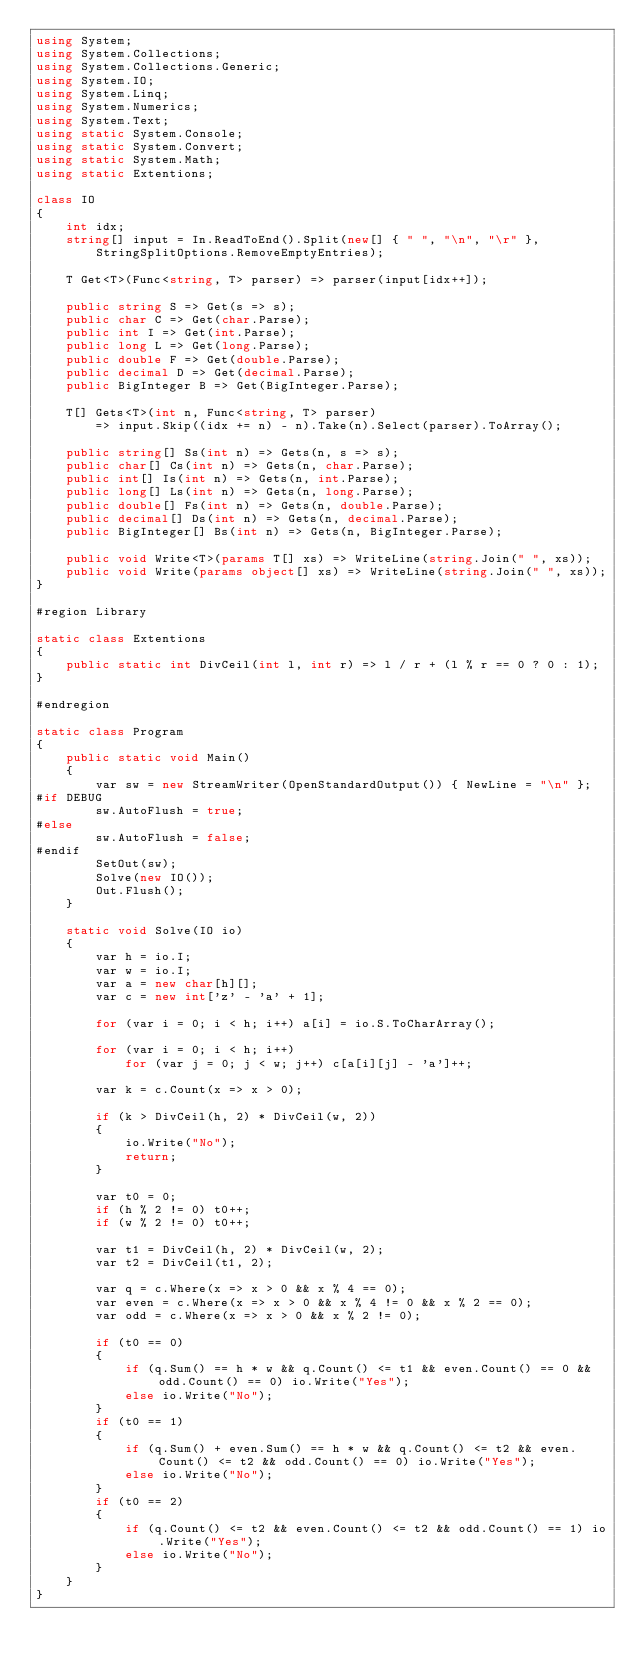<code> <loc_0><loc_0><loc_500><loc_500><_C#_>using System;
using System.Collections;
using System.Collections.Generic;
using System.IO;
using System.Linq;
using System.Numerics;
using System.Text;
using static System.Console;
using static System.Convert;
using static System.Math;
using static Extentions;

class IO
{
    int idx;
    string[] input = In.ReadToEnd().Split(new[] { " ", "\n", "\r" },
        StringSplitOptions.RemoveEmptyEntries);

    T Get<T>(Func<string, T> parser) => parser(input[idx++]);

    public string S => Get(s => s);
    public char C => Get(char.Parse);
    public int I => Get(int.Parse);
    public long L => Get(long.Parse);
    public double F => Get(double.Parse);
    public decimal D => Get(decimal.Parse);
    public BigInteger B => Get(BigInteger.Parse);

    T[] Gets<T>(int n, Func<string, T> parser)
        => input.Skip((idx += n) - n).Take(n).Select(parser).ToArray();

    public string[] Ss(int n) => Gets(n, s => s);
    public char[] Cs(int n) => Gets(n, char.Parse);
    public int[] Is(int n) => Gets(n, int.Parse);
    public long[] Ls(int n) => Gets(n, long.Parse);
    public double[] Fs(int n) => Gets(n, double.Parse);
    public decimal[] Ds(int n) => Gets(n, decimal.Parse);
    public BigInteger[] Bs(int n) => Gets(n, BigInteger.Parse);

    public void Write<T>(params T[] xs) => WriteLine(string.Join(" ", xs));
    public void Write(params object[] xs) => WriteLine(string.Join(" ", xs));
}

#region Library

static class Extentions
{
    public static int DivCeil(int l, int r) => l / r + (l % r == 0 ? 0 : 1);
}

#endregion

static class Program
{
    public static void Main()
    {
        var sw = new StreamWriter(OpenStandardOutput()) { NewLine = "\n" };
#if DEBUG
        sw.AutoFlush = true;
#else
        sw.AutoFlush = false;
#endif
        SetOut(sw);
        Solve(new IO());
        Out.Flush();
    }

    static void Solve(IO io)
    {
        var h = io.I;
        var w = io.I;
        var a = new char[h][];
        var c = new int['z' - 'a' + 1];

        for (var i = 0; i < h; i++) a[i] = io.S.ToCharArray();

        for (var i = 0; i < h; i++)
            for (var j = 0; j < w; j++) c[a[i][j] - 'a']++;

        var k = c.Count(x => x > 0);

        if (k > DivCeil(h, 2) * DivCeil(w, 2))
        {
            io.Write("No");
            return;
        }

        var t0 = 0;
        if (h % 2 != 0) t0++;
        if (w % 2 != 0) t0++;

        var t1 = DivCeil(h, 2) * DivCeil(w, 2);
        var t2 = DivCeil(t1, 2);

        var q = c.Where(x => x > 0 && x % 4 == 0);
        var even = c.Where(x => x > 0 && x % 4 != 0 && x % 2 == 0);
        var odd = c.Where(x => x > 0 && x % 2 != 0);

        if (t0 == 0)
        {
            if (q.Sum() == h * w && q.Count() <= t1 && even.Count() == 0 && odd.Count() == 0) io.Write("Yes");
            else io.Write("No");
        }
        if (t0 == 1)
        {
            if (q.Sum() + even.Sum() == h * w && q.Count() <= t2 && even.Count() <= t2 && odd.Count() == 0) io.Write("Yes");
            else io.Write("No");
        }
        if (t0 == 2)
        {
            if (q.Count() <= t2 && even.Count() <= t2 && odd.Count() == 1) io.Write("Yes");
            else io.Write("No");
        }
    }
}</code> 